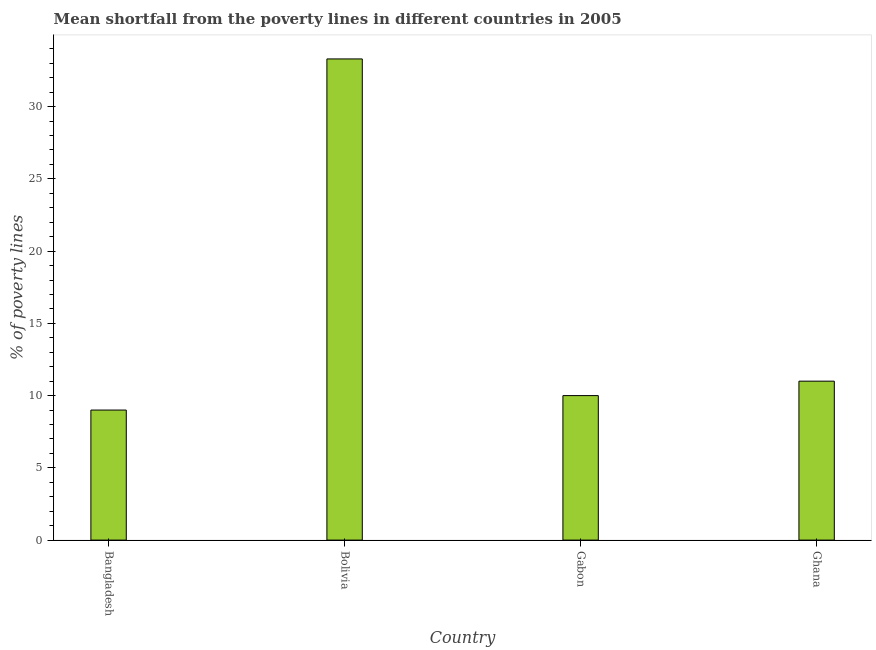Does the graph contain grids?
Keep it short and to the point. No. What is the title of the graph?
Your answer should be compact. Mean shortfall from the poverty lines in different countries in 2005. What is the label or title of the X-axis?
Make the answer very short. Country. What is the label or title of the Y-axis?
Your response must be concise. % of poverty lines. What is the poverty gap at national poverty lines in Bolivia?
Make the answer very short. 33.3. Across all countries, what is the maximum poverty gap at national poverty lines?
Keep it short and to the point. 33.3. Across all countries, what is the minimum poverty gap at national poverty lines?
Offer a terse response. 9. In which country was the poverty gap at national poverty lines maximum?
Ensure brevity in your answer.  Bolivia. What is the sum of the poverty gap at national poverty lines?
Give a very brief answer. 63.3. What is the difference between the poverty gap at national poverty lines in Bolivia and Gabon?
Your answer should be very brief. 23.3. What is the average poverty gap at national poverty lines per country?
Provide a short and direct response. 15.82. In how many countries, is the poverty gap at national poverty lines greater than 28 %?
Your response must be concise. 1. What is the ratio of the poverty gap at national poverty lines in Gabon to that in Ghana?
Offer a very short reply. 0.91. What is the difference between the highest and the second highest poverty gap at national poverty lines?
Your answer should be very brief. 22.3. Is the sum of the poverty gap at national poverty lines in Gabon and Ghana greater than the maximum poverty gap at national poverty lines across all countries?
Make the answer very short. No. What is the difference between the highest and the lowest poverty gap at national poverty lines?
Provide a short and direct response. 24.3. How many bars are there?
Provide a succinct answer. 4. What is the difference between two consecutive major ticks on the Y-axis?
Offer a terse response. 5. Are the values on the major ticks of Y-axis written in scientific E-notation?
Provide a succinct answer. No. What is the % of poverty lines of Bolivia?
Your answer should be very brief. 33.3. What is the difference between the % of poverty lines in Bangladesh and Bolivia?
Your answer should be very brief. -24.3. What is the difference between the % of poverty lines in Bangladesh and Gabon?
Offer a very short reply. -1. What is the difference between the % of poverty lines in Bolivia and Gabon?
Your answer should be compact. 23.3. What is the difference between the % of poverty lines in Bolivia and Ghana?
Offer a terse response. 22.3. What is the difference between the % of poverty lines in Gabon and Ghana?
Your answer should be compact. -1. What is the ratio of the % of poverty lines in Bangladesh to that in Bolivia?
Give a very brief answer. 0.27. What is the ratio of the % of poverty lines in Bangladesh to that in Gabon?
Provide a succinct answer. 0.9. What is the ratio of the % of poverty lines in Bangladesh to that in Ghana?
Provide a short and direct response. 0.82. What is the ratio of the % of poverty lines in Bolivia to that in Gabon?
Keep it short and to the point. 3.33. What is the ratio of the % of poverty lines in Bolivia to that in Ghana?
Make the answer very short. 3.03. What is the ratio of the % of poverty lines in Gabon to that in Ghana?
Give a very brief answer. 0.91. 